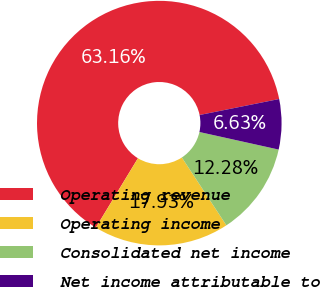<chart> <loc_0><loc_0><loc_500><loc_500><pie_chart><fcel>Operating revenue<fcel>Operating income<fcel>Consolidated net income<fcel>Net income attributable to<nl><fcel>63.15%<fcel>17.93%<fcel>12.28%<fcel>6.63%<nl></chart> 